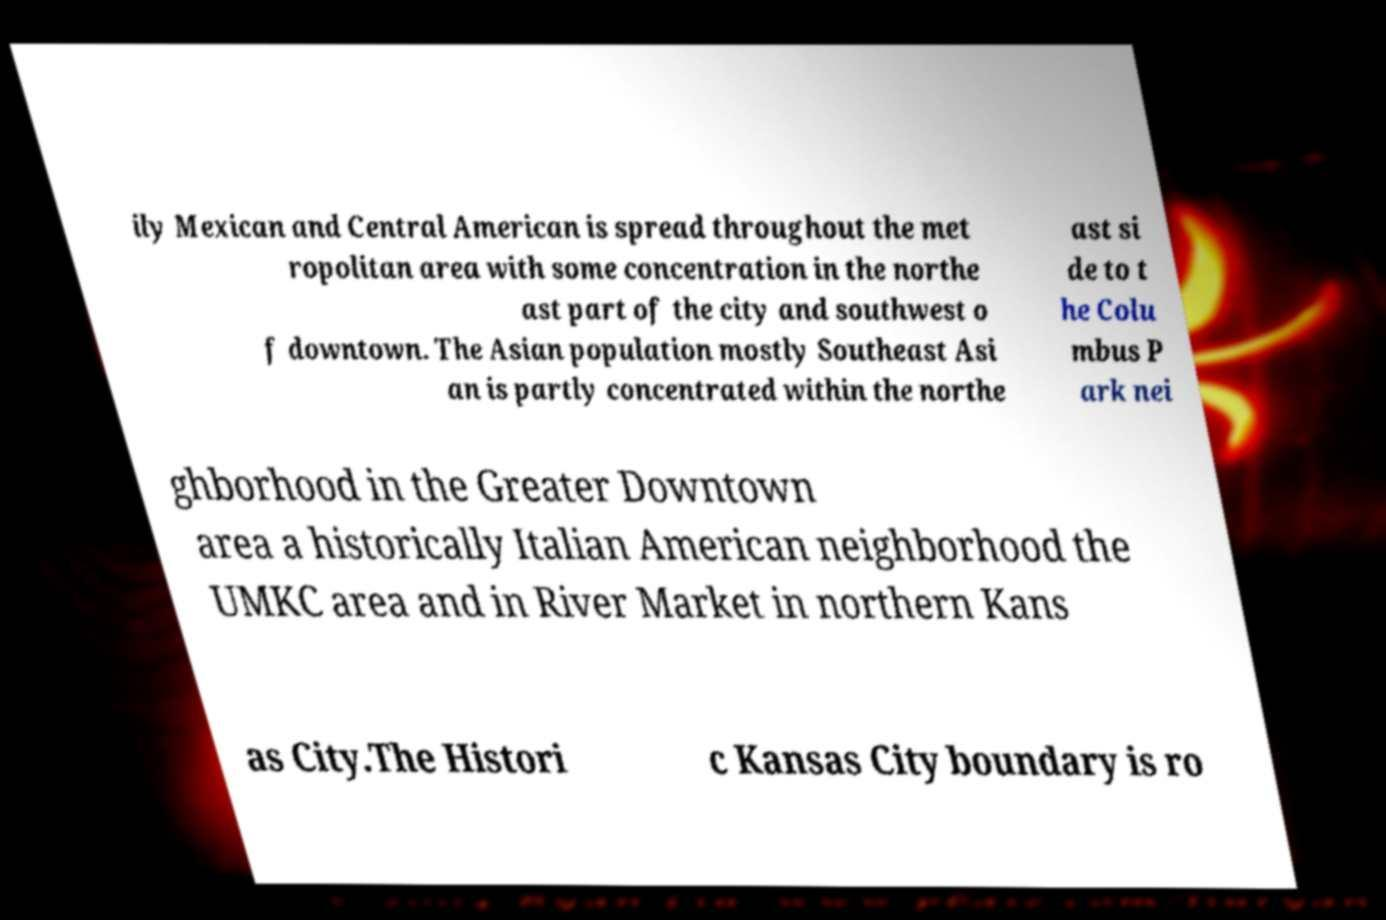Can you accurately transcribe the text from the provided image for me? ily Mexican and Central American is spread throughout the met ropolitan area with some concentration in the northe ast part of the city and southwest o f downtown. The Asian population mostly Southeast Asi an is partly concentrated within the northe ast si de to t he Colu mbus P ark nei ghborhood in the Greater Downtown area a historically Italian American neighborhood the UMKC area and in River Market in northern Kans as City.The Histori c Kansas City boundary is ro 